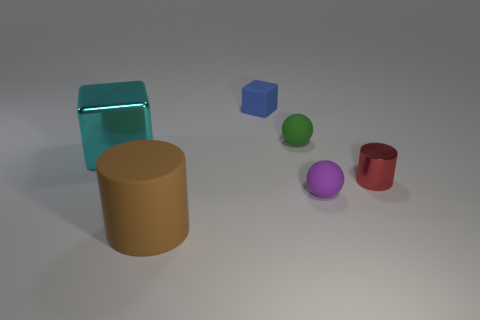Can you infer anything about the lighting in this scene? The lighting in this scene seems to be diffused, coming from a source above and possibly slightly in front of the objects. There are soft shadows cast directly underneath and slightly to the side of each object, indicating the light source is slightly angled. The lack of harsh shadows or strong highlights implies that the light is not very intense, or may be softened by some form of diffusion, such as a softbox or overcast sky in a natural setting. 